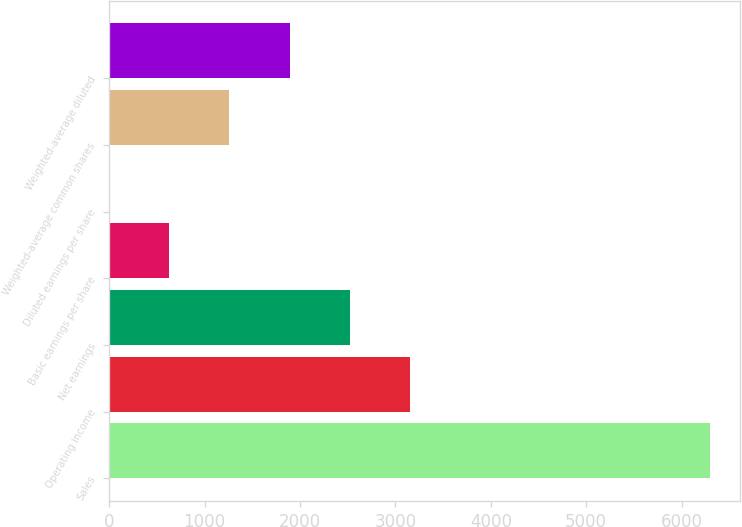Convert chart. <chart><loc_0><loc_0><loc_500><loc_500><bar_chart><fcel>Sales<fcel>Operating income<fcel>Net earnings<fcel>Basic earnings per share<fcel>Diluted earnings per share<fcel>Weighted-average common shares<fcel>Weighted-average diluted<nl><fcel>6294<fcel>3148.04<fcel>2518.84<fcel>631.25<fcel>2.05<fcel>1260.45<fcel>1889.64<nl></chart> 